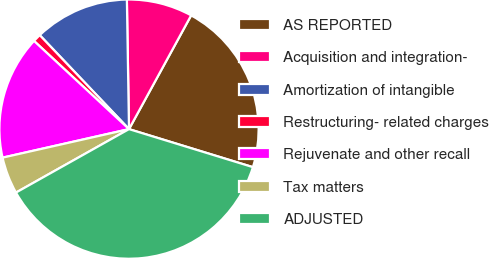<chart> <loc_0><loc_0><loc_500><loc_500><pie_chart><fcel>AS REPORTED<fcel>Acquisition and integration-<fcel>Amortization of intangible<fcel>Restructuring- related charges<fcel>Rejuvenate and other recall<fcel>Tax matters<fcel>ADJUSTED<nl><fcel>21.78%<fcel>8.22%<fcel>11.83%<fcel>1.0%<fcel>15.44%<fcel>4.61%<fcel>37.12%<nl></chart> 